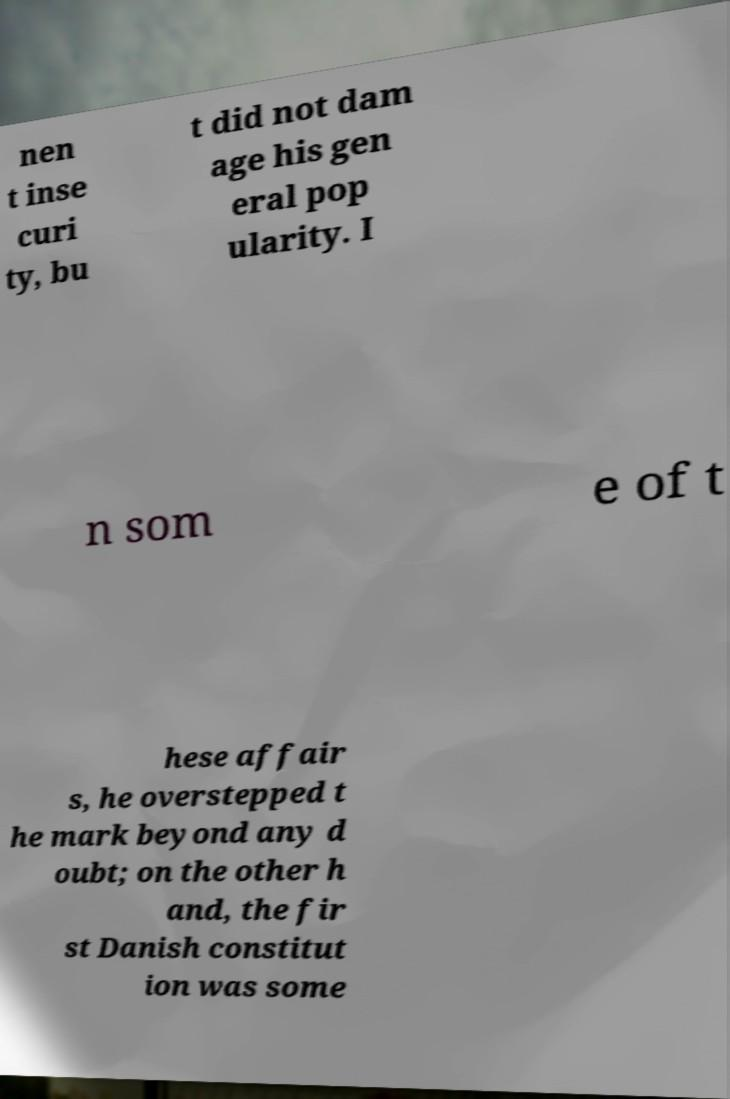What messages or text are displayed in this image? I need them in a readable, typed format. nen t inse curi ty, bu t did not dam age his gen eral pop ularity. I n som e of t hese affair s, he overstepped t he mark beyond any d oubt; on the other h and, the fir st Danish constitut ion was some 